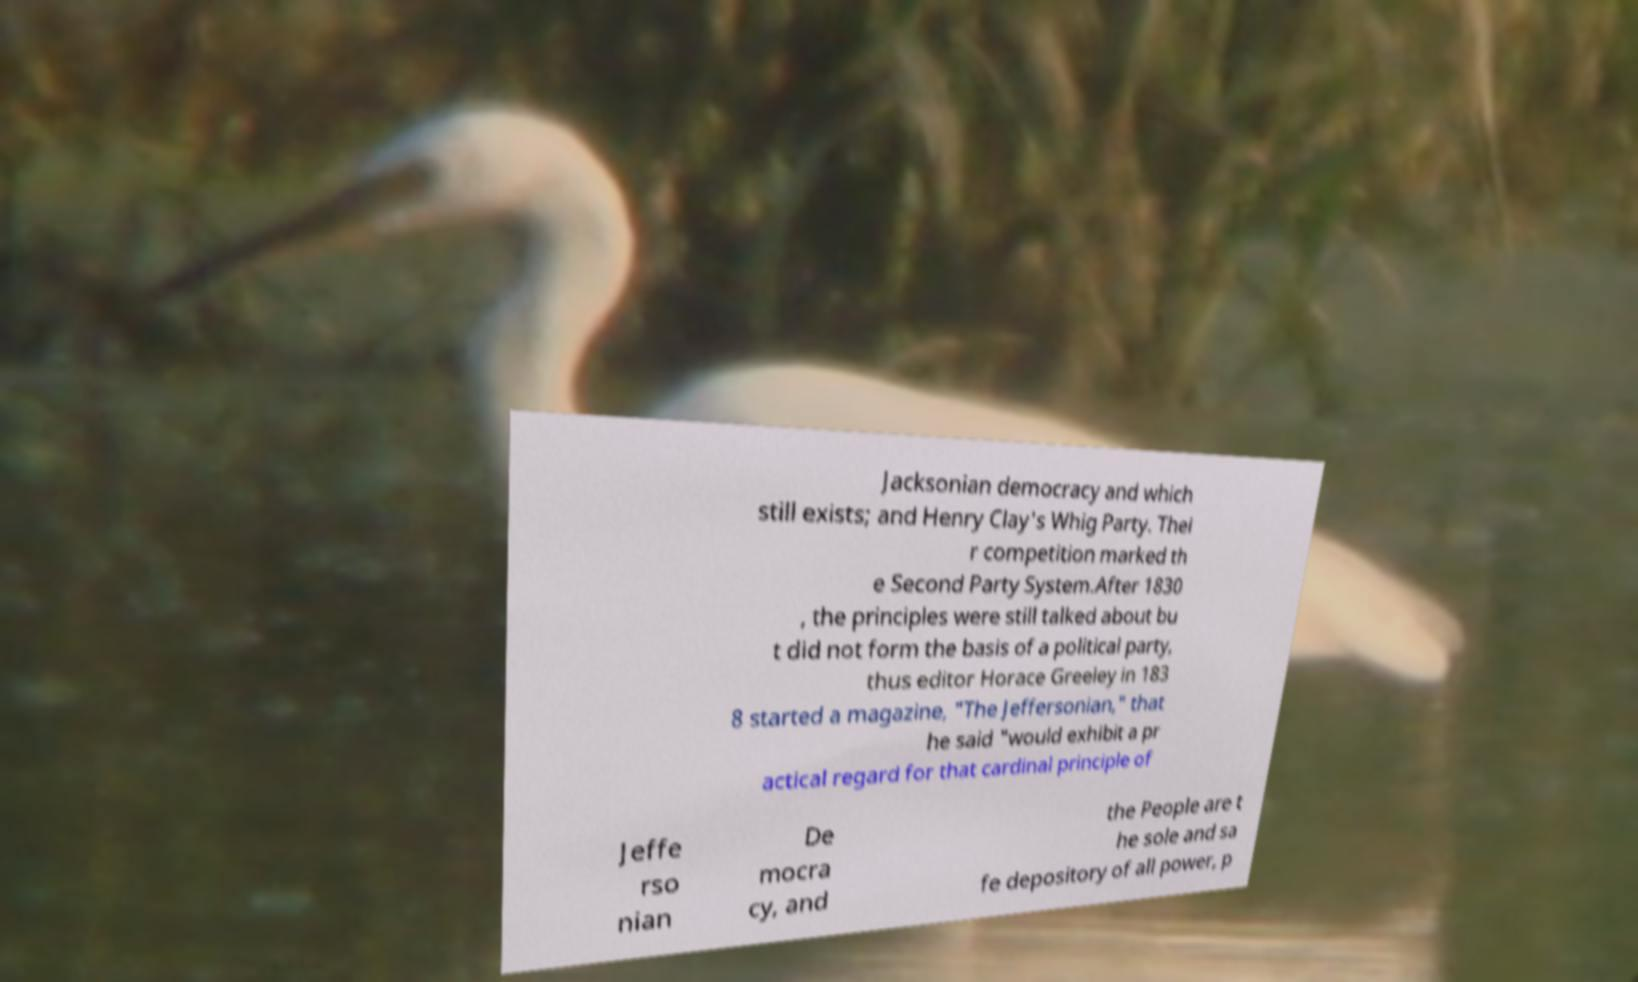Could you assist in decoding the text presented in this image and type it out clearly? Jacksonian democracy and which still exists; and Henry Clay's Whig Party. Thei r competition marked th e Second Party System.After 1830 , the principles were still talked about bu t did not form the basis of a political party, thus editor Horace Greeley in 183 8 started a magazine, "The Jeffersonian," that he said "would exhibit a pr actical regard for that cardinal principle of Jeffe rso nian De mocra cy, and the People are t he sole and sa fe depository of all power, p 